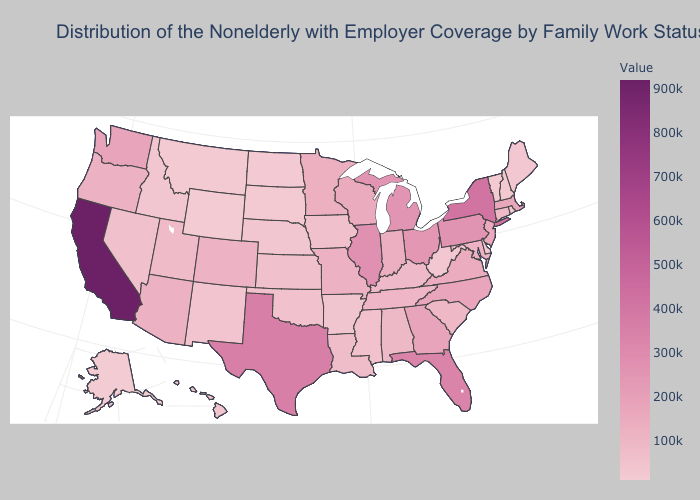Does the map have missing data?
Concise answer only. No. Does California have the highest value in the West?
Give a very brief answer. Yes. Is the legend a continuous bar?
Give a very brief answer. Yes. Among the states that border Michigan , which have the lowest value?
Answer briefly. Indiana. Does New York have the highest value in the Northeast?
Quick response, please. Yes. 